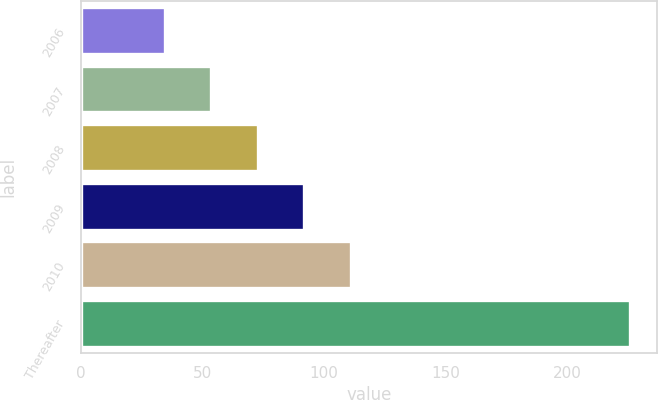Convert chart. <chart><loc_0><loc_0><loc_500><loc_500><bar_chart><fcel>2006<fcel>2007<fcel>2008<fcel>2009<fcel>2010<fcel>Thereafter<nl><fcel>34.5<fcel>53.6<fcel>72.7<fcel>91.8<fcel>110.9<fcel>225.5<nl></chart> 